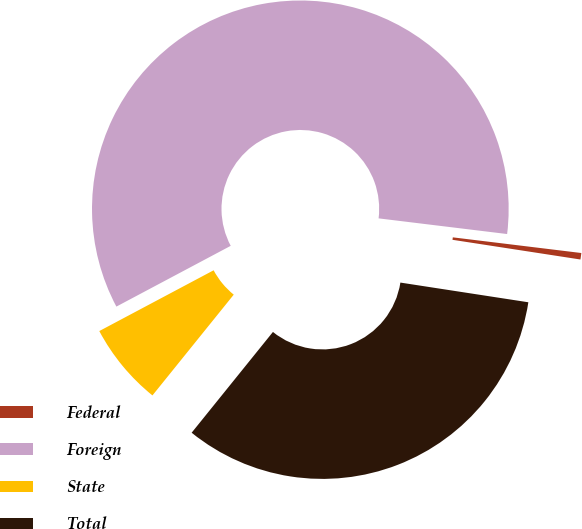Convert chart to OTSL. <chart><loc_0><loc_0><loc_500><loc_500><pie_chart><fcel>Federal<fcel>Foreign<fcel>State<fcel>Total<nl><fcel>0.5%<fcel>59.7%<fcel>6.42%<fcel>33.37%<nl></chart> 